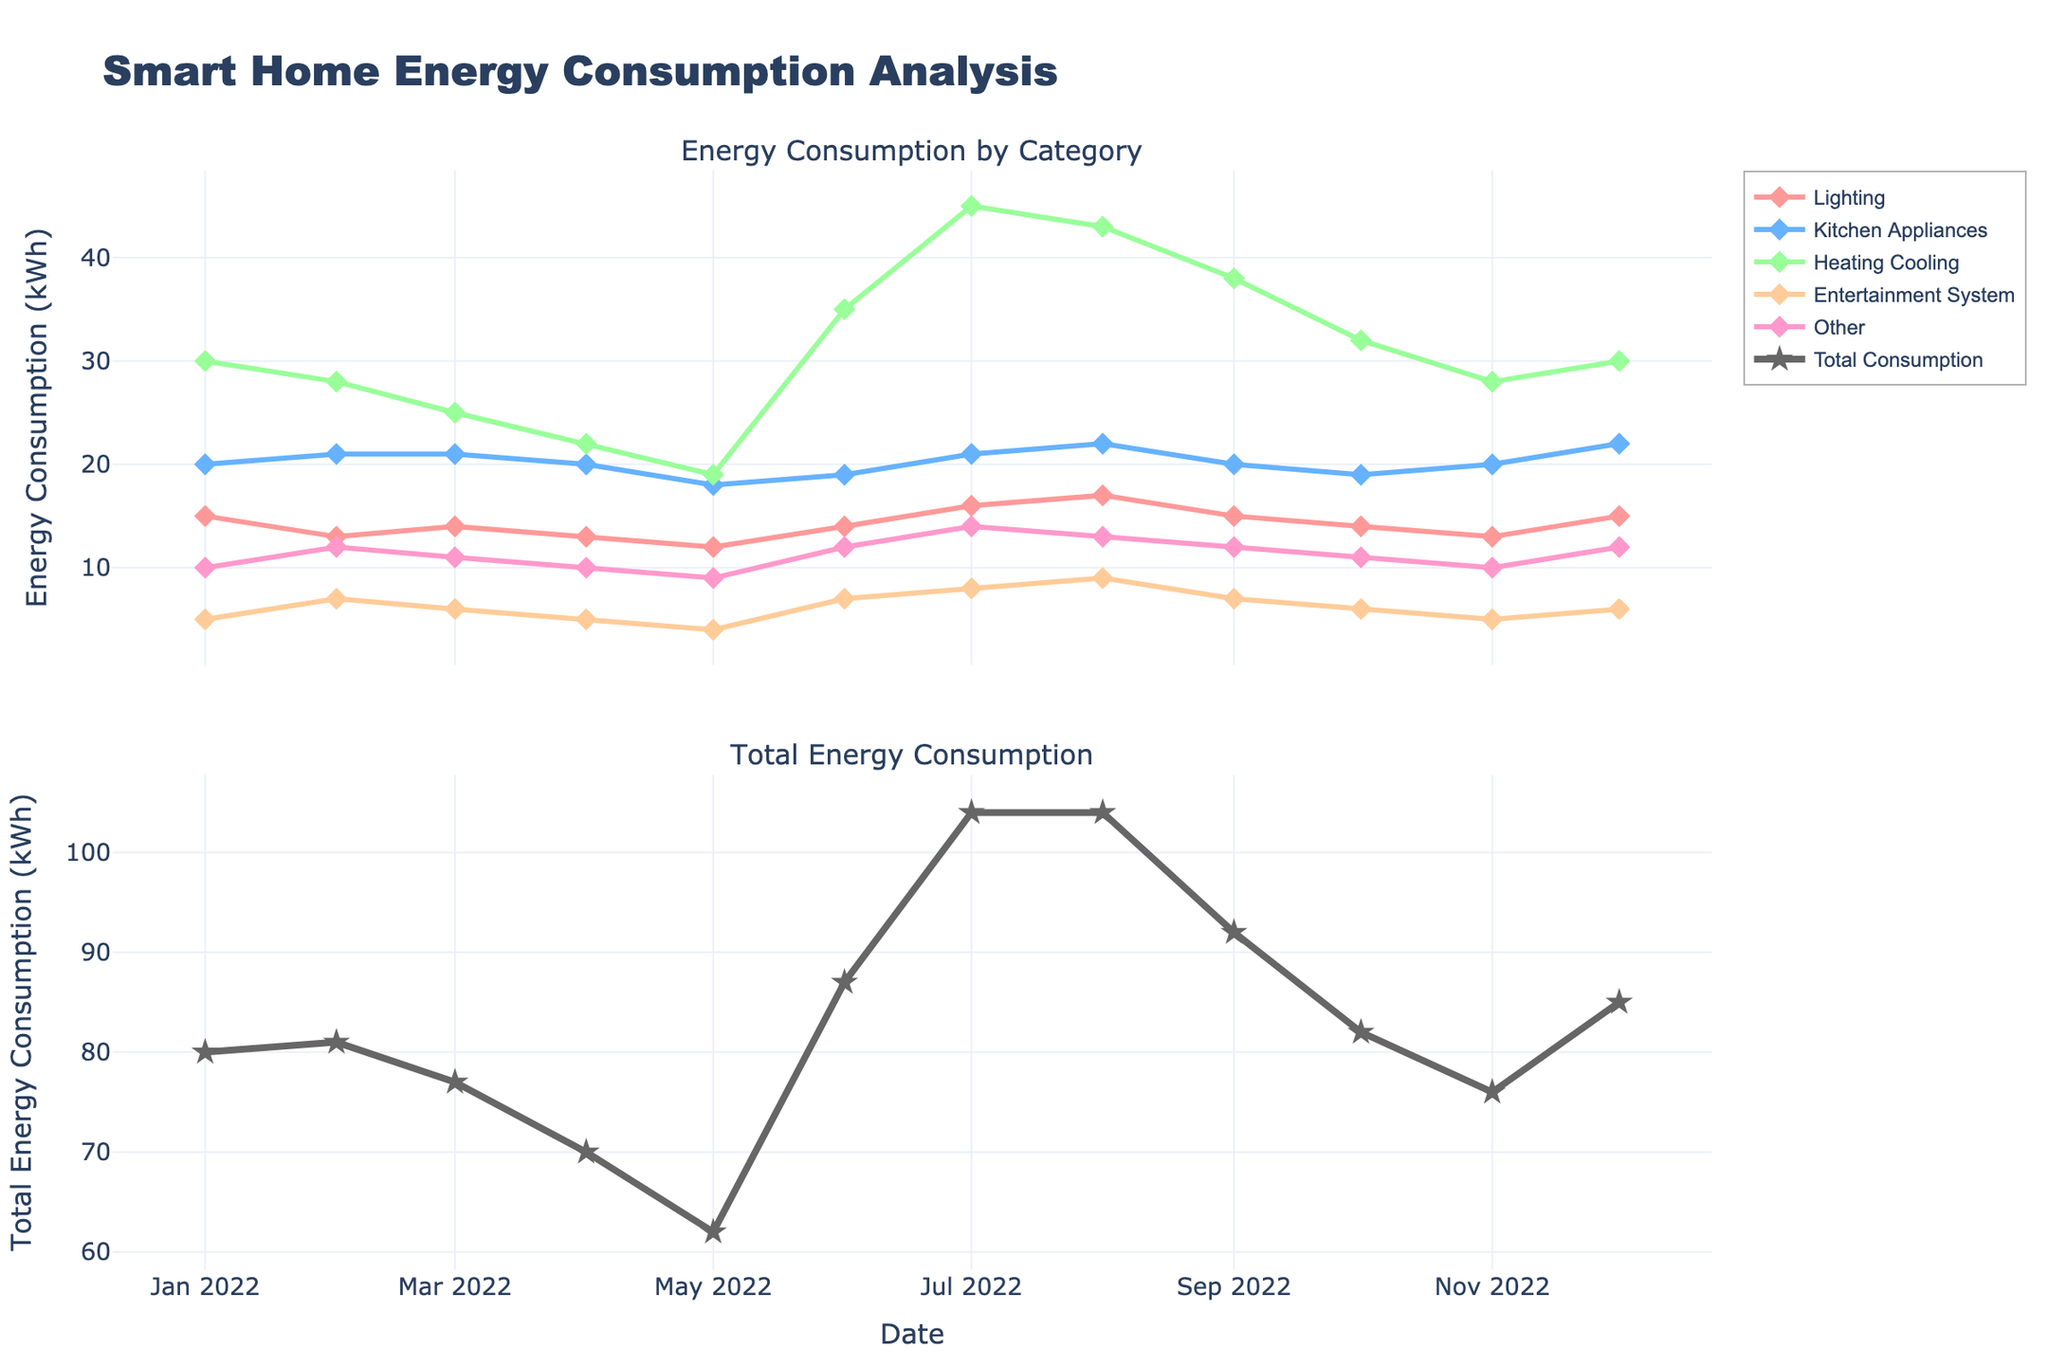What is the title of the plot? The title is displayed at the top of the plot, which is "Smart Home Energy Consumption Analysis".
Answer: Smart Home Energy Consumption Analysis How many subplots does the figure have? The figure has two subplots organized vertically.
Answer: 2 Which category has the highest energy consumption in July? In July, the "heating and cooling" category reaches its peak among all the categories.
Answer: heating and cooling What is the overall trend of energy consumption for the "lighting" category throughout the year? The energy consumption for the "lighting" category fluctuates slightly but overall remains relatively steady throughout the year.
Answer: steady What is the total energy consumption in February? To find the total energy consumption in February, sum the energy consumption of all categories in that month: 13 (lighting) + 21 (kitchen appliances) + 28 (heating and cooling) + 7 (entertainment system) + 12 (other) = 81 kWh.
Answer: 81 kWh Which month has the lowest total energy consumption? By comparing the total consumption values for each month, May has the lowest total consumption (12 + 18 + 19 + 4 + 9 = 62 kWh).
Answer: May How does the energy consumption of the "entertainment system" category in June compare to August? The consumption of the "entertainment system" is 7 kWh in June and 9 kWh in August. Therefore, it is lower in June than in August.
Answer: lower Is there any category that shows a significant seasonal pattern? The "heating and cooling" category shows a significant seasonal pattern, with higher consumption in summer (June, July, August) and lower in spring and fall.
Answer: yes What is the average energy consumption for the "kitchen appliances" category over the year? Sum the consumption values for each month for "kitchen appliances" and divide by 12: (20 + 21 + 21 + 20 + 18 + 19 + 21 + 22 + 20 + 19 + 20 + 22) / 12 = 20.25 kWh.
Answer: 20.25 kWh How does the total energy consumption in August compare to December? Comparing the total energy consumption: August (17 + 22 + 43 + 9 + 13 = 104 kWh) is higher than December (15 + 22 + 30 + 6 + 12 = 85 kWh).
Answer: higher 